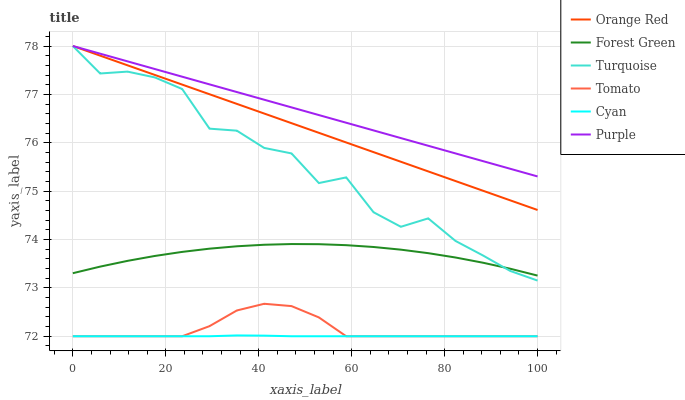Does Turquoise have the minimum area under the curve?
Answer yes or no. No. Does Turquoise have the maximum area under the curve?
Answer yes or no. No. Is Turquoise the smoothest?
Answer yes or no. No. Is Purple the roughest?
Answer yes or no. No. Does Turquoise have the lowest value?
Answer yes or no. No. Does Forest Green have the highest value?
Answer yes or no. No. Is Cyan less than Orange Red?
Answer yes or no. Yes. Is Forest Green greater than Tomato?
Answer yes or no. Yes. Does Cyan intersect Orange Red?
Answer yes or no. No. 